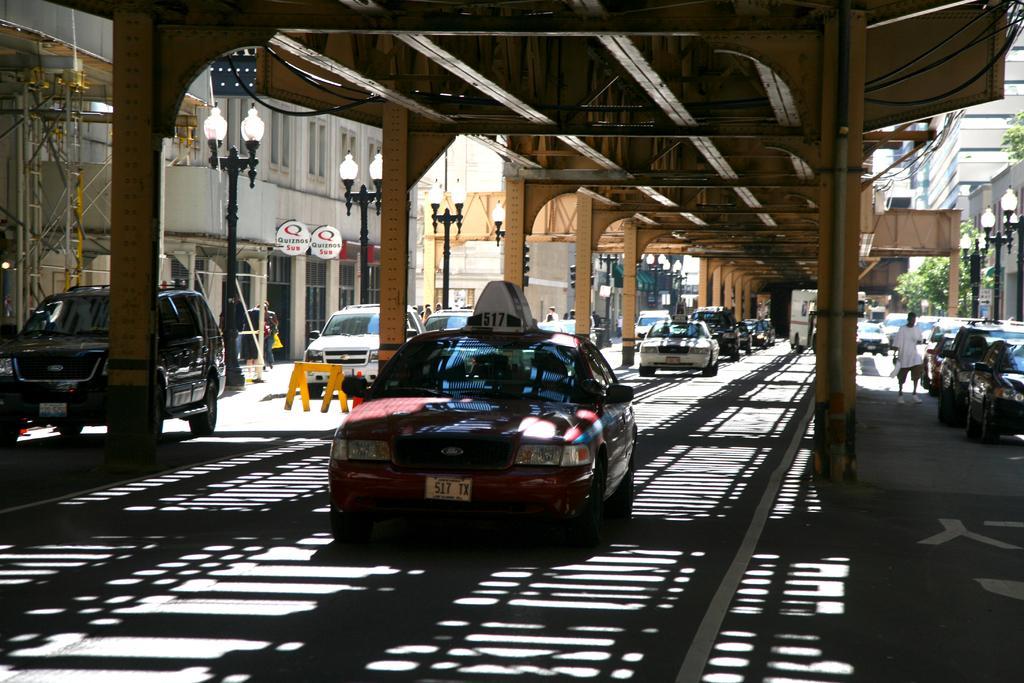How would you summarize this image in a sentence or two? There is a car in the foreground area of the image, there are people, vehicles, buildings, poles, it seems like subway and the sky in the background. 